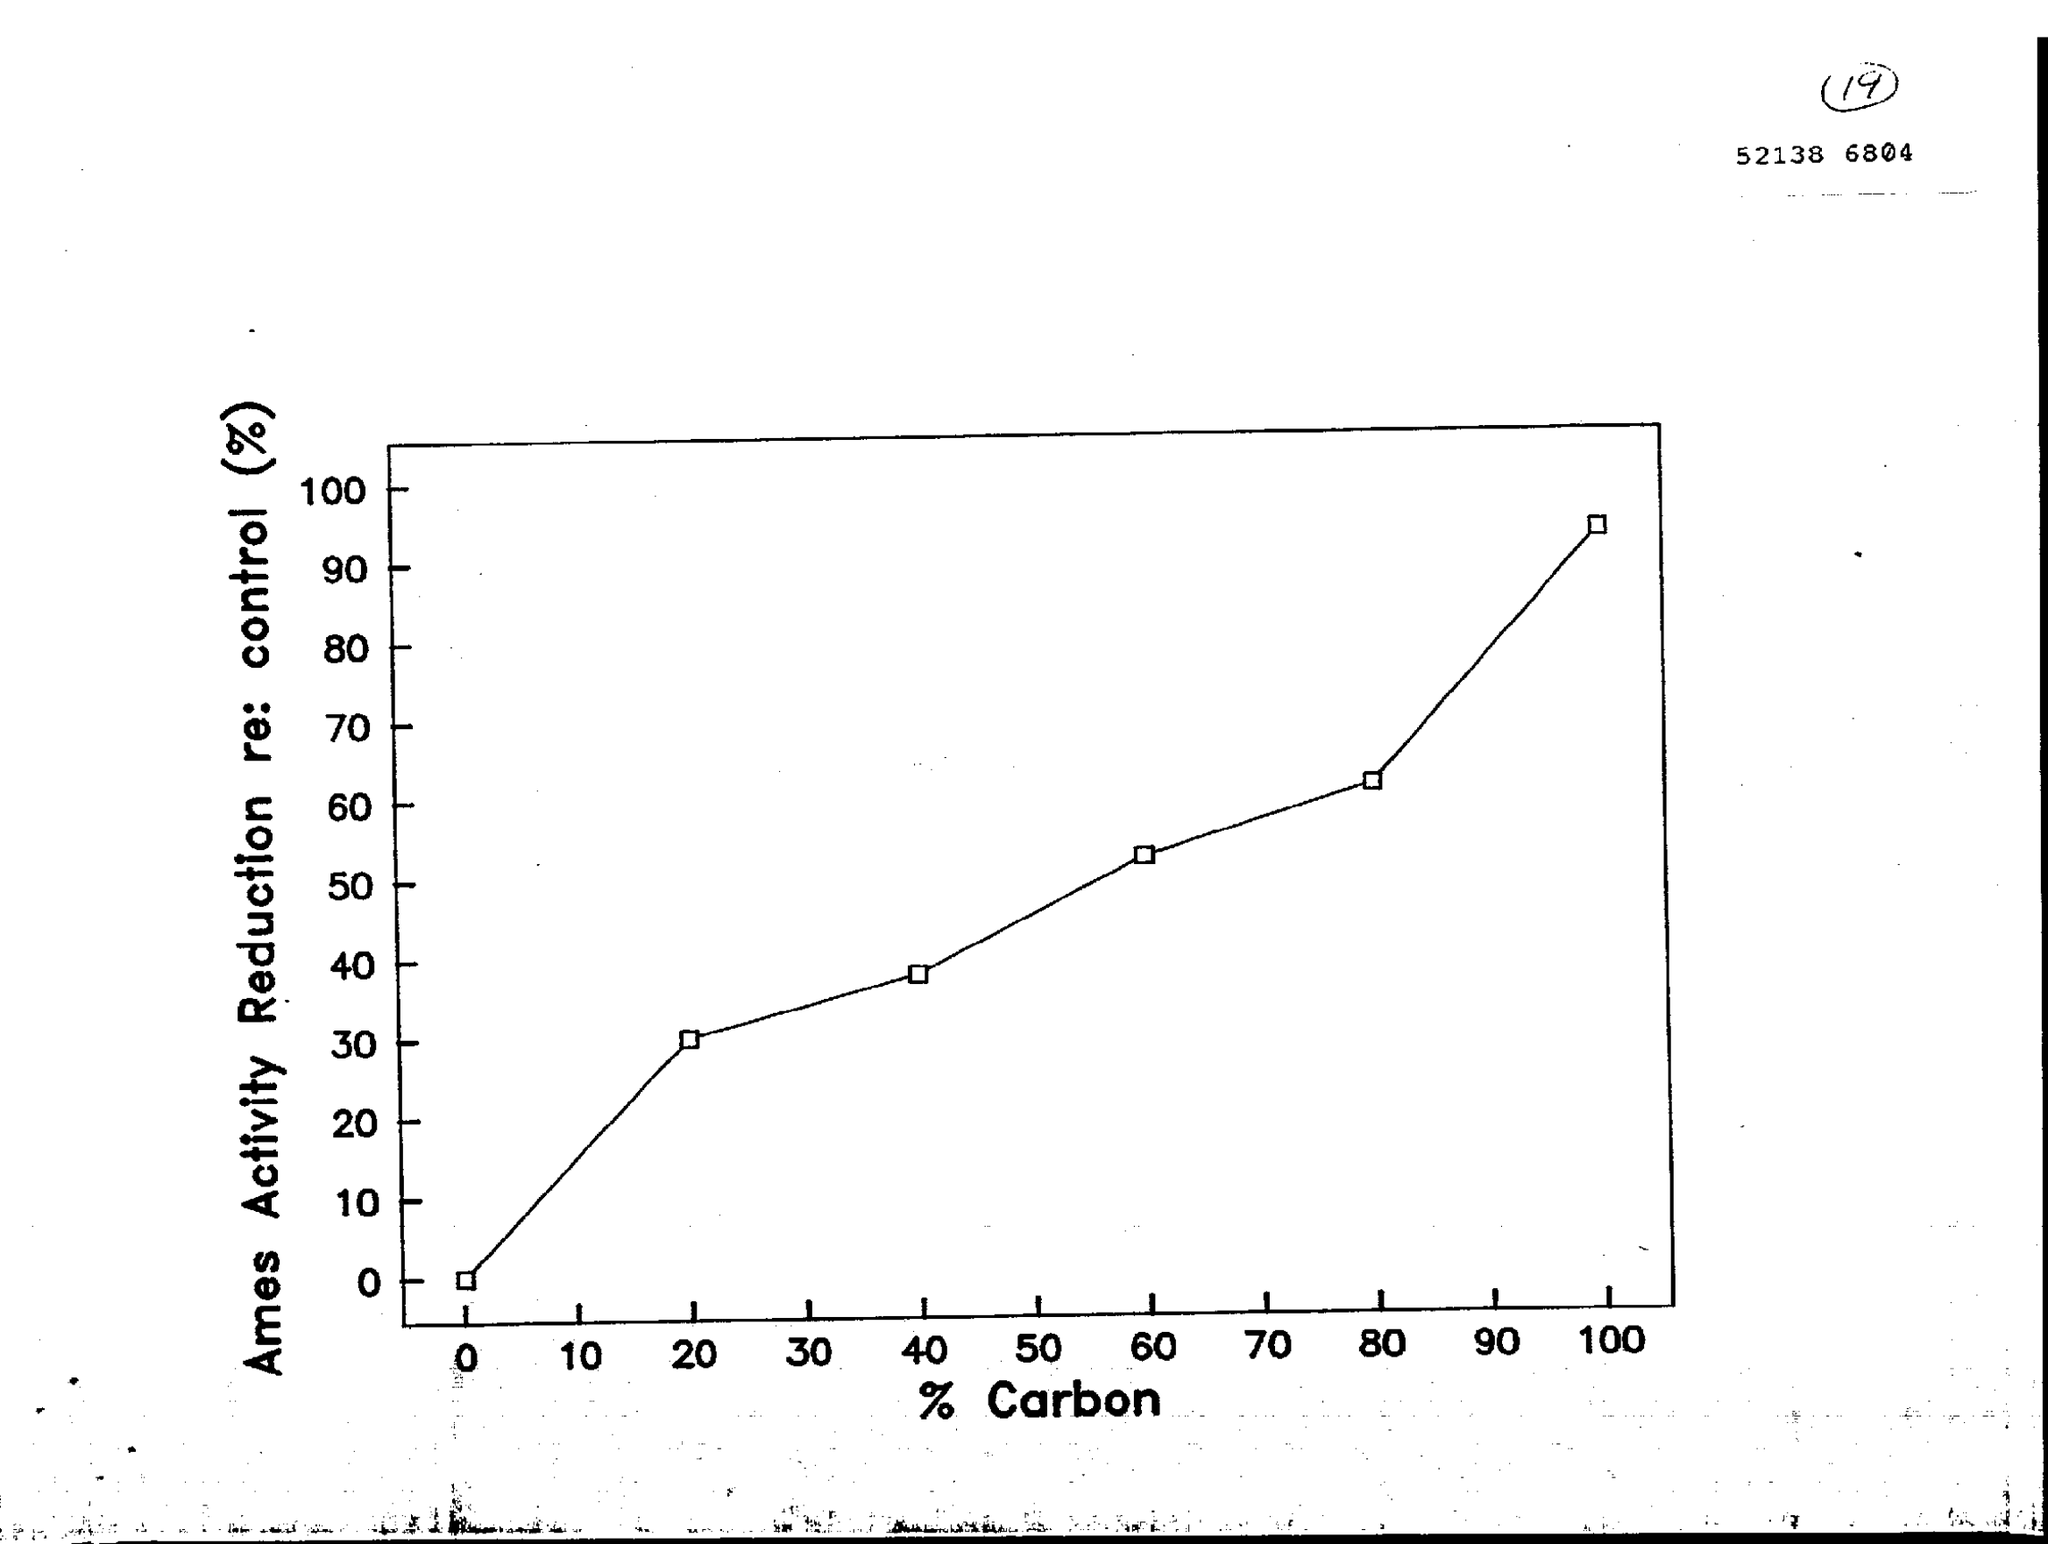What is the variable on X axis of the graph?
Your response must be concise. % Carbon. What is the variable on Y axis of the graph?
Provide a short and direct response. Ames Activity Reduction re: control (%). 